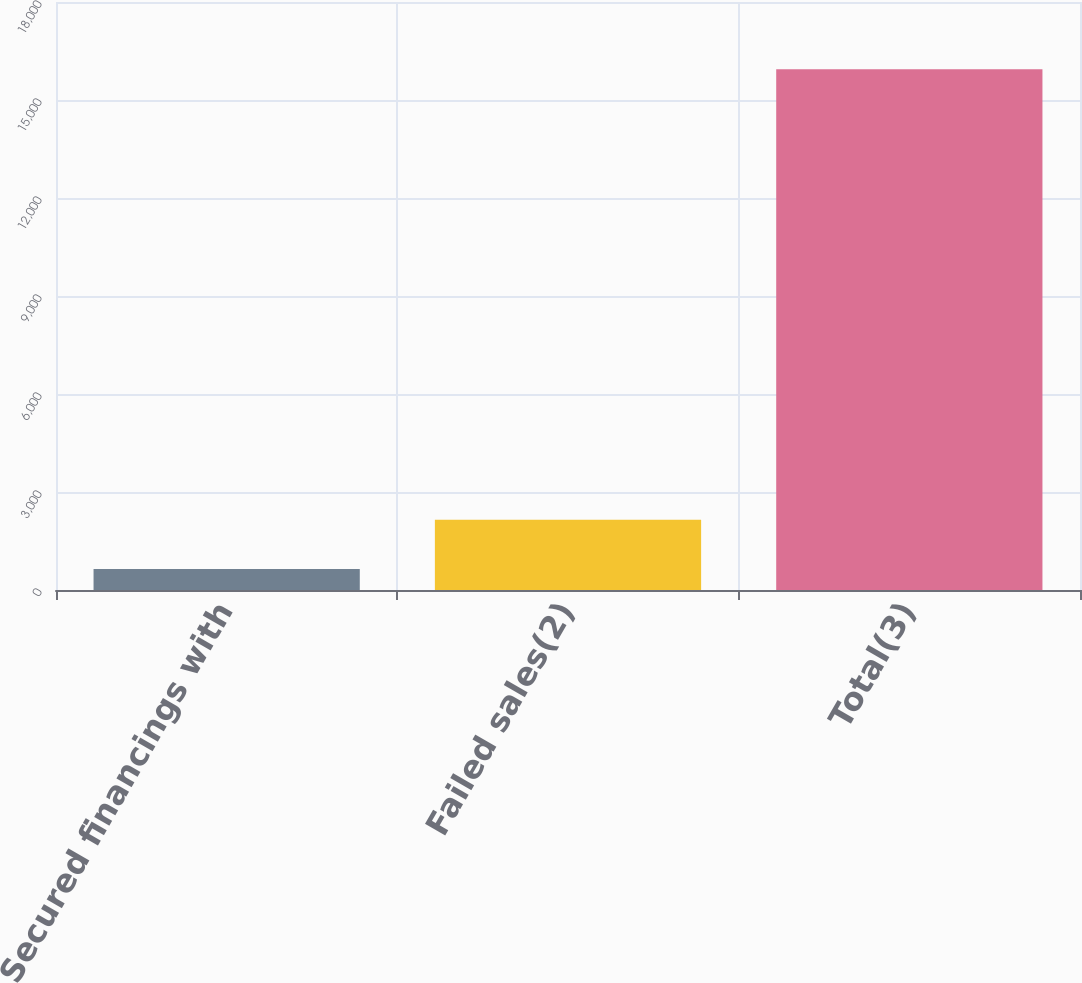<chart> <loc_0><loc_0><loc_500><loc_500><bar_chart><fcel>Secured financings with<fcel>Failed sales(2)<fcel>Total(3)<nl><fcel>641<fcel>2149.6<fcel>15939.6<nl></chart> 